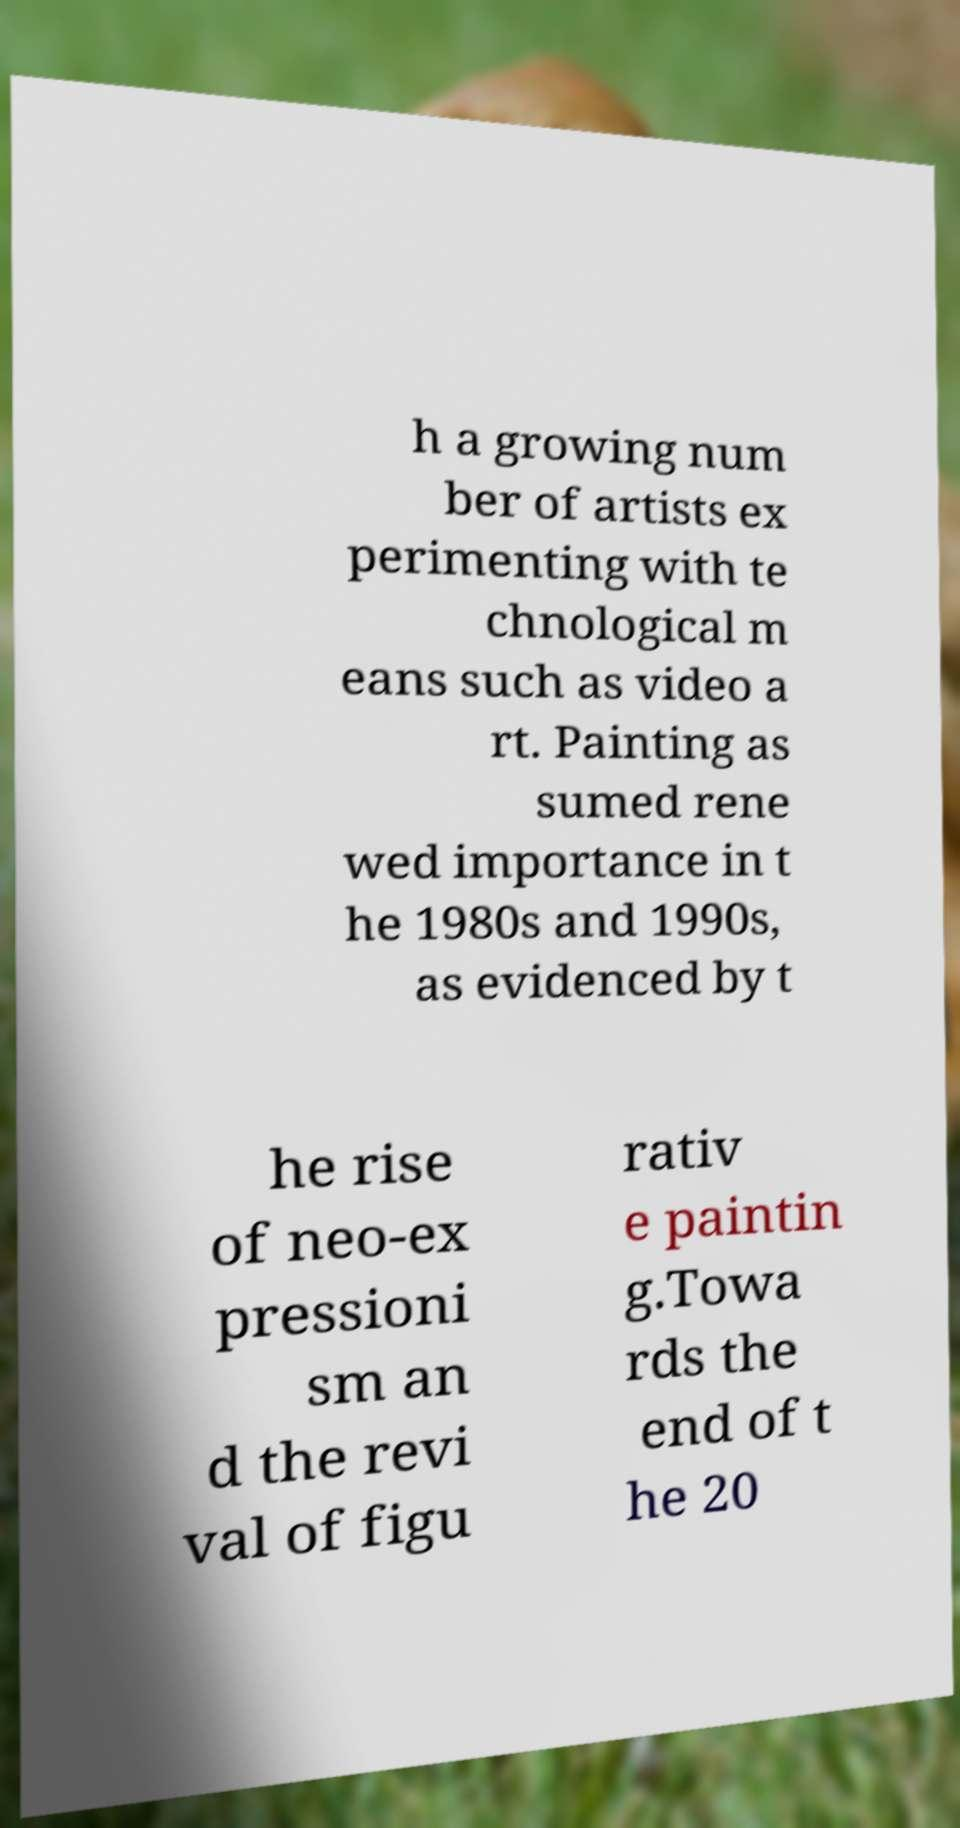Please read and relay the text visible in this image. What does it say? h a growing num ber of artists ex perimenting with te chnological m eans such as video a rt. Painting as sumed rene wed importance in t he 1980s and 1990s, as evidenced by t he rise of neo-ex pressioni sm an d the revi val of figu rativ e paintin g.Towa rds the end of t he 20 